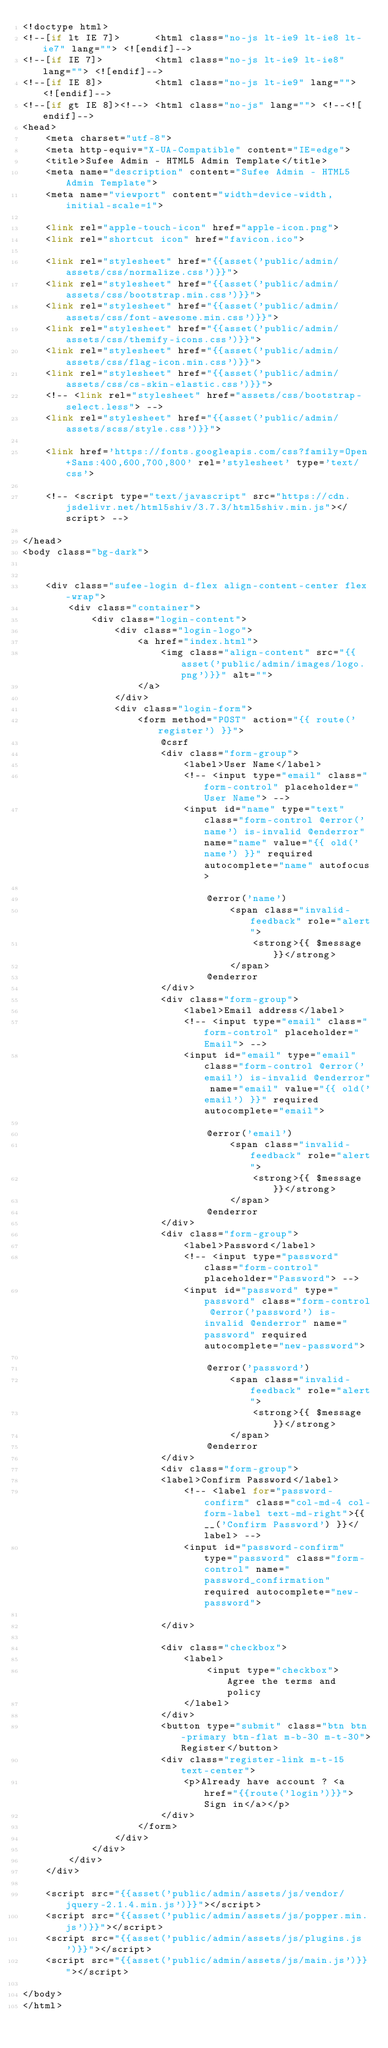Convert code to text. <code><loc_0><loc_0><loc_500><loc_500><_PHP_><!doctype html>
<!--[if lt IE 7]>      <html class="no-js lt-ie9 lt-ie8 lt-ie7" lang=""> <![endif]-->
<!--[if IE 7]>         <html class="no-js lt-ie9 lt-ie8" lang=""> <![endif]-->
<!--[if IE 8]>         <html class="no-js lt-ie9" lang=""> <![endif]-->
<!--[if gt IE 8]><!--> <html class="no-js" lang=""> <!--<![endif]-->
<head>
    <meta charset="utf-8">
    <meta http-equiv="X-UA-Compatible" content="IE=edge">
    <title>Sufee Admin - HTML5 Admin Template</title>
    <meta name="description" content="Sufee Admin - HTML5 Admin Template">
    <meta name="viewport" content="width=device-width, initial-scale=1">

    <link rel="apple-touch-icon" href="apple-icon.png">
    <link rel="shortcut icon" href="favicon.ico">

    <link rel="stylesheet" href="{{asset('public/admin/assets/css/normalize.css')}}">
    <link rel="stylesheet" href="{{asset('public/admin/assets/css/bootstrap.min.css')}}">
    <link rel="stylesheet" href="{{asset('public/admin/assets/css/font-awesome.min.css')}}">
    <link rel="stylesheet" href="{{asset('public/admin/assets/css/themify-icons.css')}}">
    <link rel="stylesheet" href="{{asset('public/admin/assets/css/flag-icon.min.css')}}">
    <link rel="stylesheet" href="{{asset('public/admin/assets/css/cs-skin-elastic.css')}}">
    <!-- <link rel="stylesheet" href="assets/css/bootstrap-select.less"> -->
    <link rel="stylesheet" href="{{asset('public/admin/assets/scss/style.css')}}">

    <link href='https://fonts.googleapis.com/css?family=Open+Sans:400,600,700,800' rel='stylesheet' type='text/css'>

    <!-- <script type="text/javascript" src="https://cdn.jsdelivr.net/html5shiv/3.7.3/html5shiv.min.js"></script> -->

</head>
<body class="bg-dark">


    <div class="sufee-login d-flex align-content-center flex-wrap">
        <div class="container">
            <div class="login-content">
                <div class="login-logo">
                    <a href="index.html">
                        <img class="align-content" src="{{asset('public/admin/images/logo.png')}}" alt="">
                    </a>
                </div>
                <div class="login-form">
                    <form method="POST" action="{{ route('register') }}">
                        @csrf
                        <div class="form-group">
                            <label>User Name</label>
                            <!-- <input type="email" class="form-control" placeholder="User Name"> -->
                            <input id="name" type="text" class="form-control @error('name') is-invalid @enderror" name="name" value="{{ old('name') }}" required autocomplete="name" autofocus>

                                @error('name')
                                    <span class="invalid-feedback" role="alert">
                                        <strong>{{ $message }}</strong>
                                    </span>
                                @enderror
                        </div>
                        <div class="form-group">
                            <label>Email address</label>
                            <!-- <input type="email" class="form-control" placeholder="Email"> -->
                            <input id="email" type="email" class="form-control @error('email') is-invalid @enderror" name="email" value="{{ old('email') }}" required autocomplete="email">

                                @error('email')
                                    <span class="invalid-feedback" role="alert">
                                        <strong>{{ $message }}</strong>
                                    </span>
                                @enderror
                        </div>
                        <div class="form-group">
                            <label>Password</label>
                            <!-- <input type="password" class="form-control" placeholder="Password"> -->
                            <input id="password" type="password" class="form-control @error('password') is-invalid @enderror" name="password" required autocomplete="new-password">

                                @error('password')
                                    <span class="invalid-feedback" role="alert">
                                        <strong>{{ $message }}</strong>
                                    </span>
                                @enderror
                        </div>
                        <div class="form-group">
                        <label>Confirm Password</label>
                            <!-- <label for="password-confirm" class="col-md-4 col-form-label text-md-right">{{ __('Confirm Password') }}</label> -->
                            <input id="password-confirm" type="password" class="form-control" name="password_confirmation" required autocomplete="new-password">

                        </div>

                        <div class="checkbox">
                            <label>
                                <input type="checkbox"> Agree the terms and policy
                            </label>
                        </div>
                        <button type="submit" class="btn btn-primary btn-flat m-b-30 m-t-30">Register</button>
                        <div class="register-link m-t-15 text-center">
                            <p>Already have account ? <a href="{{route('login')}}"> Sign in</a></p>
                        </div>
                    </form>
                </div>
            </div>
        </div>
    </div>

    <script src="{{asset('public/admin/assets/js/vendor/jquery-2.1.4.min.js')}}"></script>
    <script src="{{asset('public/admin/assets/js/popper.min.js')}}"></script>
    <script src="{{asset('public/admin/assets/js/plugins.js')}}"></script>
    <script src="{{asset('public/admin/assets/js/main.js')}}"></script>

</body>
</html>
</code> 